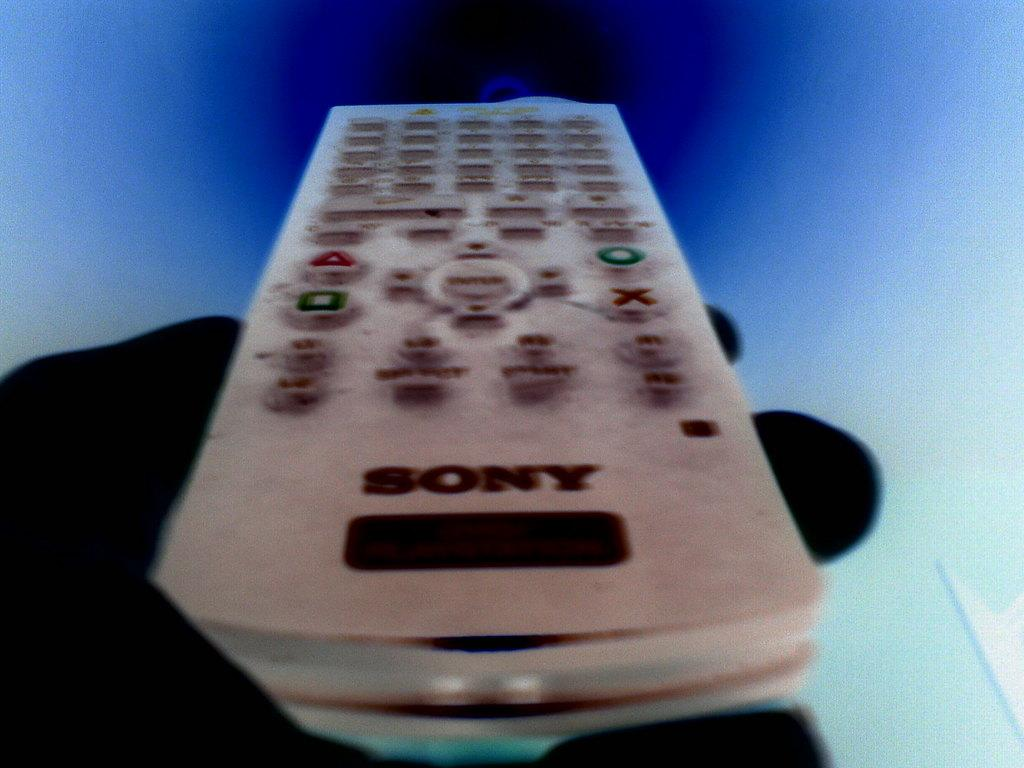<image>
Render a clear and concise summary of the photo. Television remote mady by Sony with play button, enter button and stop button. 